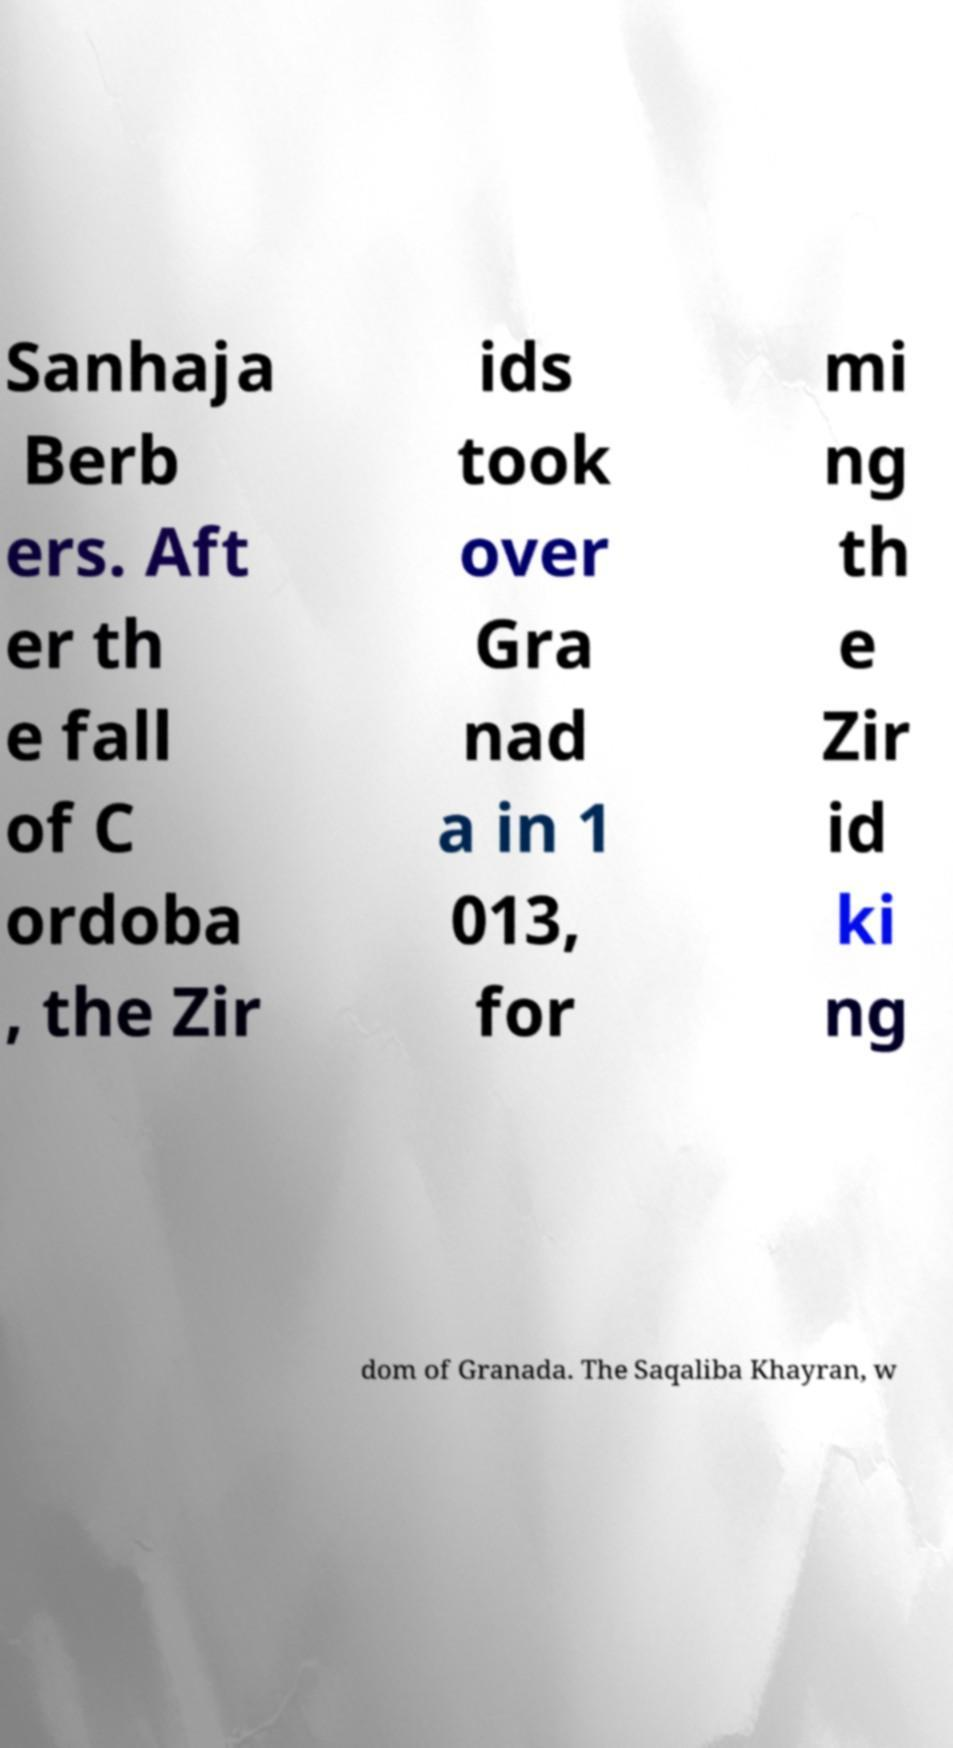Please read and relay the text visible in this image. What does it say? Sanhaja Berb ers. Aft er th e fall of C ordoba , the Zir ids took over Gra nad a in 1 013, for mi ng th e Zir id ki ng dom of Granada. The Saqaliba Khayran, w 